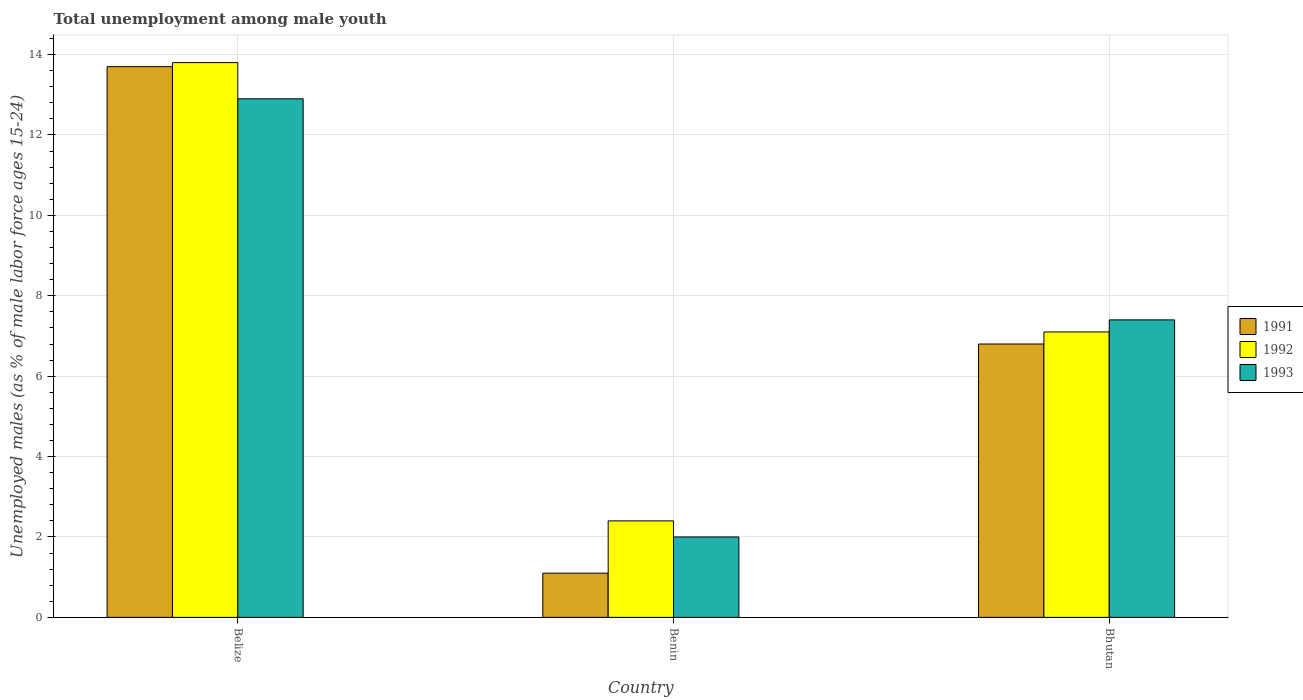How many groups of bars are there?
Provide a succinct answer. 3. Are the number of bars on each tick of the X-axis equal?
Keep it short and to the point. Yes. How many bars are there on the 3rd tick from the right?
Ensure brevity in your answer.  3. What is the label of the 3rd group of bars from the left?
Keep it short and to the point. Bhutan. In how many cases, is the number of bars for a given country not equal to the number of legend labels?
Ensure brevity in your answer.  0. What is the percentage of unemployed males in in 1993 in Belize?
Offer a terse response. 12.9. Across all countries, what is the maximum percentage of unemployed males in in 1993?
Offer a terse response. 12.9. Across all countries, what is the minimum percentage of unemployed males in in 1991?
Keep it short and to the point. 1.1. In which country was the percentage of unemployed males in in 1991 maximum?
Ensure brevity in your answer.  Belize. In which country was the percentage of unemployed males in in 1992 minimum?
Provide a succinct answer. Benin. What is the total percentage of unemployed males in in 1992 in the graph?
Keep it short and to the point. 23.3. What is the difference between the percentage of unemployed males in in 1991 in Belize and that in Benin?
Your answer should be compact. 12.6. What is the difference between the percentage of unemployed males in in 1991 in Benin and the percentage of unemployed males in in 1992 in Bhutan?
Your response must be concise. -6. What is the average percentage of unemployed males in in 1992 per country?
Make the answer very short. 7.77. What is the difference between the percentage of unemployed males in of/in 1993 and percentage of unemployed males in of/in 1991 in Bhutan?
Provide a succinct answer. 0.6. What is the ratio of the percentage of unemployed males in in 1991 in Benin to that in Bhutan?
Your answer should be compact. 0.16. Is the difference between the percentage of unemployed males in in 1993 in Belize and Benin greater than the difference between the percentage of unemployed males in in 1991 in Belize and Benin?
Offer a terse response. No. What is the difference between the highest and the second highest percentage of unemployed males in in 1991?
Provide a succinct answer. -12.6. What is the difference between the highest and the lowest percentage of unemployed males in in 1992?
Offer a terse response. 11.4. Is the sum of the percentage of unemployed males in in 1991 in Belize and Bhutan greater than the maximum percentage of unemployed males in in 1992 across all countries?
Provide a succinct answer. Yes. What does the 2nd bar from the left in Benin represents?
Your response must be concise. 1992. Is it the case that in every country, the sum of the percentage of unemployed males in in 1991 and percentage of unemployed males in in 1992 is greater than the percentage of unemployed males in in 1993?
Provide a succinct answer. Yes. Are all the bars in the graph horizontal?
Give a very brief answer. No. How many countries are there in the graph?
Keep it short and to the point. 3. What is the difference between two consecutive major ticks on the Y-axis?
Provide a short and direct response. 2. Does the graph contain any zero values?
Offer a very short reply. No. How many legend labels are there?
Give a very brief answer. 3. How are the legend labels stacked?
Your answer should be very brief. Vertical. What is the title of the graph?
Make the answer very short. Total unemployment among male youth. What is the label or title of the X-axis?
Offer a terse response. Country. What is the label or title of the Y-axis?
Your answer should be compact. Unemployed males (as % of male labor force ages 15-24). What is the Unemployed males (as % of male labor force ages 15-24) of 1991 in Belize?
Keep it short and to the point. 13.7. What is the Unemployed males (as % of male labor force ages 15-24) in 1992 in Belize?
Keep it short and to the point. 13.8. What is the Unemployed males (as % of male labor force ages 15-24) in 1993 in Belize?
Give a very brief answer. 12.9. What is the Unemployed males (as % of male labor force ages 15-24) of 1991 in Benin?
Keep it short and to the point. 1.1. What is the Unemployed males (as % of male labor force ages 15-24) in 1992 in Benin?
Your answer should be compact. 2.4. What is the Unemployed males (as % of male labor force ages 15-24) of 1991 in Bhutan?
Your answer should be compact. 6.8. What is the Unemployed males (as % of male labor force ages 15-24) of 1992 in Bhutan?
Provide a short and direct response. 7.1. What is the Unemployed males (as % of male labor force ages 15-24) in 1993 in Bhutan?
Keep it short and to the point. 7.4. Across all countries, what is the maximum Unemployed males (as % of male labor force ages 15-24) in 1991?
Offer a very short reply. 13.7. Across all countries, what is the maximum Unemployed males (as % of male labor force ages 15-24) of 1992?
Provide a succinct answer. 13.8. Across all countries, what is the maximum Unemployed males (as % of male labor force ages 15-24) of 1993?
Provide a succinct answer. 12.9. Across all countries, what is the minimum Unemployed males (as % of male labor force ages 15-24) of 1991?
Your answer should be compact. 1.1. Across all countries, what is the minimum Unemployed males (as % of male labor force ages 15-24) in 1992?
Provide a short and direct response. 2.4. Across all countries, what is the minimum Unemployed males (as % of male labor force ages 15-24) in 1993?
Ensure brevity in your answer.  2. What is the total Unemployed males (as % of male labor force ages 15-24) of 1991 in the graph?
Keep it short and to the point. 21.6. What is the total Unemployed males (as % of male labor force ages 15-24) in 1992 in the graph?
Your answer should be compact. 23.3. What is the total Unemployed males (as % of male labor force ages 15-24) of 1993 in the graph?
Give a very brief answer. 22.3. What is the difference between the Unemployed males (as % of male labor force ages 15-24) of 1991 in Belize and that in Benin?
Offer a terse response. 12.6. What is the difference between the Unemployed males (as % of male labor force ages 15-24) in 1992 in Belize and that in Benin?
Your answer should be very brief. 11.4. What is the difference between the Unemployed males (as % of male labor force ages 15-24) of 1993 in Belize and that in Benin?
Keep it short and to the point. 10.9. What is the difference between the Unemployed males (as % of male labor force ages 15-24) of 1993 in Belize and that in Bhutan?
Give a very brief answer. 5.5. What is the difference between the Unemployed males (as % of male labor force ages 15-24) of 1991 in Benin and that in Bhutan?
Make the answer very short. -5.7. What is the difference between the Unemployed males (as % of male labor force ages 15-24) of 1991 in Belize and the Unemployed males (as % of male labor force ages 15-24) of 1993 in Benin?
Keep it short and to the point. 11.7. What is the difference between the Unemployed males (as % of male labor force ages 15-24) in 1992 in Benin and the Unemployed males (as % of male labor force ages 15-24) in 1993 in Bhutan?
Your answer should be very brief. -5. What is the average Unemployed males (as % of male labor force ages 15-24) of 1992 per country?
Offer a terse response. 7.77. What is the average Unemployed males (as % of male labor force ages 15-24) in 1993 per country?
Keep it short and to the point. 7.43. What is the difference between the Unemployed males (as % of male labor force ages 15-24) in 1991 and Unemployed males (as % of male labor force ages 15-24) in 1992 in Belize?
Provide a succinct answer. -0.1. What is the difference between the Unemployed males (as % of male labor force ages 15-24) of 1991 and Unemployed males (as % of male labor force ages 15-24) of 1993 in Belize?
Provide a succinct answer. 0.8. What is the difference between the Unemployed males (as % of male labor force ages 15-24) of 1992 and Unemployed males (as % of male labor force ages 15-24) of 1993 in Belize?
Your response must be concise. 0.9. What is the difference between the Unemployed males (as % of male labor force ages 15-24) of 1991 and Unemployed males (as % of male labor force ages 15-24) of 1993 in Bhutan?
Offer a very short reply. -0.6. What is the ratio of the Unemployed males (as % of male labor force ages 15-24) of 1991 in Belize to that in Benin?
Offer a terse response. 12.45. What is the ratio of the Unemployed males (as % of male labor force ages 15-24) of 1992 in Belize to that in Benin?
Ensure brevity in your answer.  5.75. What is the ratio of the Unemployed males (as % of male labor force ages 15-24) in 1993 in Belize to that in Benin?
Offer a terse response. 6.45. What is the ratio of the Unemployed males (as % of male labor force ages 15-24) in 1991 in Belize to that in Bhutan?
Your answer should be very brief. 2.01. What is the ratio of the Unemployed males (as % of male labor force ages 15-24) of 1992 in Belize to that in Bhutan?
Provide a short and direct response. 1.94. What is the ratio of the Unemployed males (as % of male labor force ages 15-24) of 1993 in Belize to that in Bhutan?
Provide a succinct answer. 1.74. What is the ratio of the Unemployed males (as % of male labor force ages 15-24) of 1991 in Benin to that in Bhutan?
Keep it short and to the point. 0.16. What is the ratio of the Unemployed males (as % of male labor force ages 15-24) of 1992 in Benin to that in Bhutan?
Keep it short and to the point. 0.34. What is the ratio of the Unemployed males (as % of male labor force ages 15-24) of 1993 in Benin to that in Bhutan?
Your answer should be compact. 0.27. What is the difference between the highest and the second highest Unemployed males (as % of male labor force ages 15-24) in 1991?
Offer a very short reply. 6.9. What is the difference between the highest and the second highest Unemployed males (as % of male labor force ages 15-24) of 1992?
Keep it short and to the point. 6.7. What is the difference between the highest and the lowest Unemployed males (as % of male labor force ages 15-24) in 1992?
Provide a succinct answer. 11.4. 